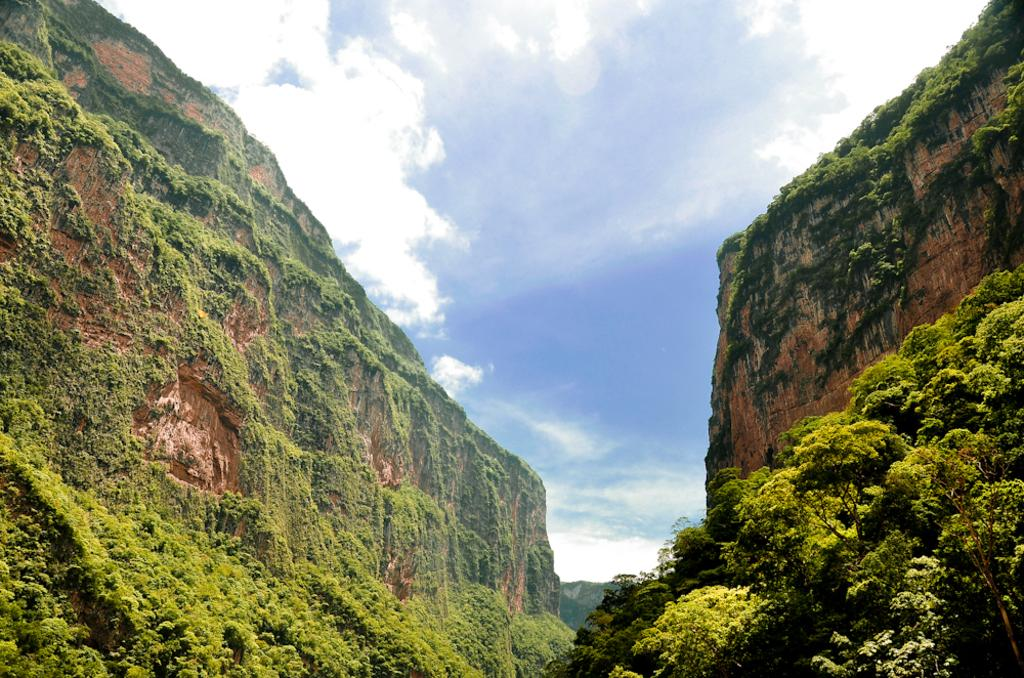What type of landscape feature is visible in the image? There are hills in the image. What other natural elements can be seen in the image? There is a group of trees in the image. How would you describe the sky in the image? The sky is cloudy at the top of the image. What type of honey is being harvested from the trees in the image? There is no honey or honey harvesting depicted in the image; it features hills and a group of trees. What type of bread is being baked on the hills in the image? There is no bread or baking activity depicted in the image; it features hills and a group of trees. 